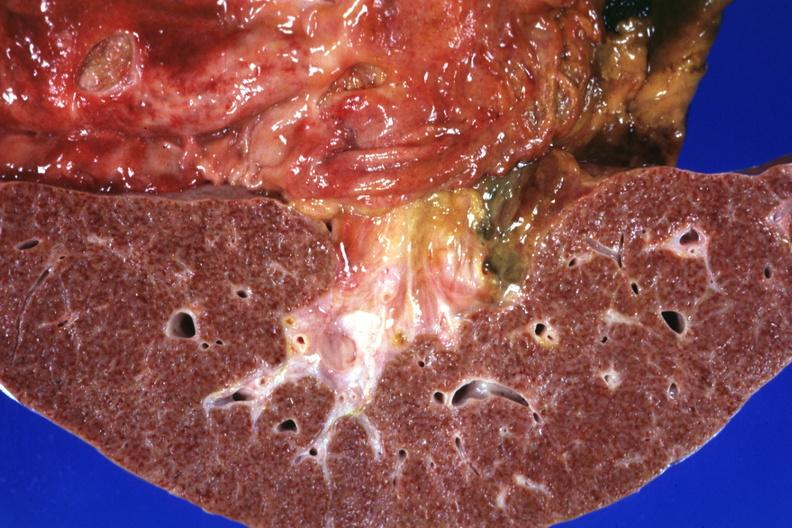how does this frontal section micronodular photo show and duodenal ulcers?
Answer the question using a single word or phrase. Gastric 